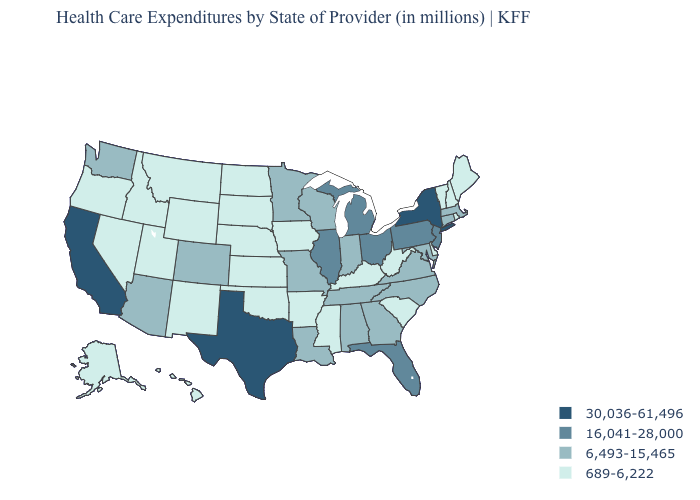Does Louisiana have a higher value than California?
Keep it brief. No. What is the value of Oklahoma?
Short answer required. 689-6,222. Name the states that have a value in the range 6,493-15,465?
Concise answer only. Alabama, Arizona, Colorado, Connecticut, Georgia, Indiana, Louisiana, Maryland, Massachusetts, Minnesota, Missouri, North Carolina, Tennessee, Virginia, Washington, Wisconsin. What is the lowest value in the USA?
Concise answer only. 689-6,222. Does Ohio have a lower value than Idaho?
Give a very brief answer. No. Name the states that have a value in the range 30,036-61,496?
Be succinct. California, New York, Texas. Among the states that border Nevada , which have the lowest value?
Answer briefly. Idaho, Oregon, Utah. Among the states that border Louisiana , does Texas have the highest value?
Concise answer only. Yes. Name the states that have a value in the range 689-6,222?
Be succinct. Alaska, Arkansas, Delaware, Hawaii, Idaho, Iowa, Kansas, Kentucky, Maine, Mississippi, Montana, Nebraska, Nevada, New Hampshire, New Mexico, North Dakota, Oklahoma, Oregon, Rhode Island, South Carolina, South Dakota, Utah, Vermont, West Virginia, Wyoming. Name the states that have a value in the range 30,036-61,496?
Quick response, please. California, New York, Texas. Does North Dakota have the highest value in the USA?
Be succinct. No. What is the value of Tennessee?
Keep it brief. 6,493-15,465. Does the first symbol in the legend represent the smallest category?
Give a very brief answer. No. Name the states that have a value in the range 16,041-28,000?
Concise answer only. Florida, Illinois, Michigan, New Jersey, Ohio, Pennsylvania. What is the value of Indiana?
Write a very short answer. 6,493-15,465. 